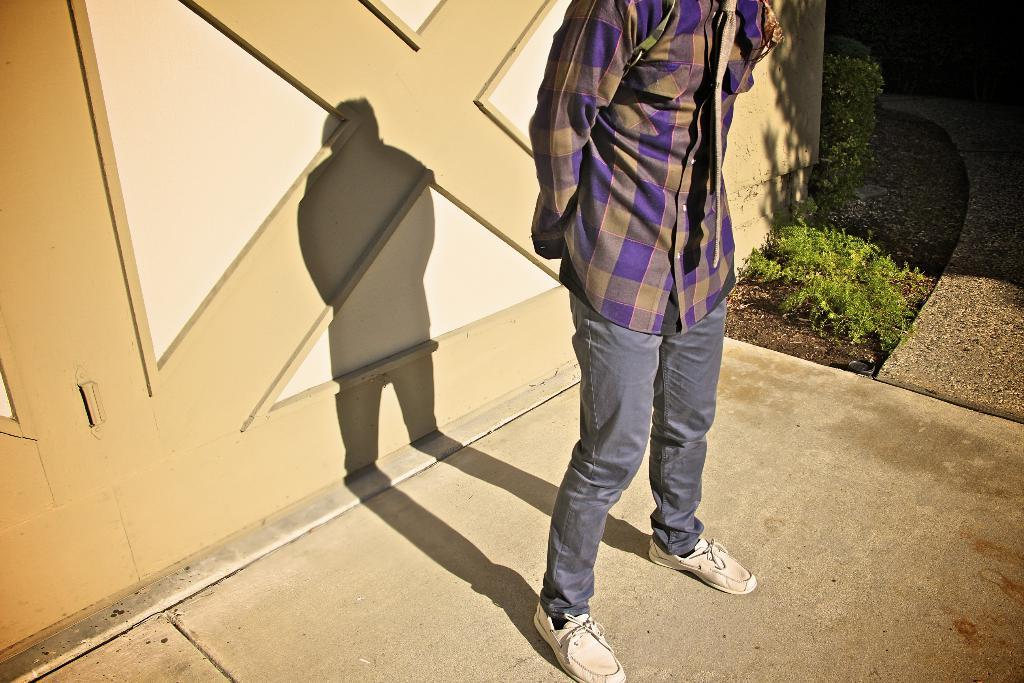What is the main subject of the image? There is a person standing in the image. What can be observed about the person's shadow in the image? The person's shadow is visible in the image. What type of vegetation is present in the image? There are plants in the image. How many horses are visible in the image? There are no horses present in the image. What type of bikes can be seen in the image? There are no bikes present in the image. 